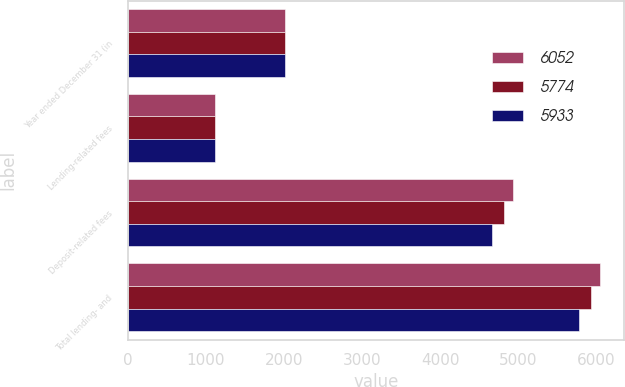<chart> <loc_0><loc_0><loc_500><loc_500><stacked_bar_chart><ecel><fcel>Year ended December 31 (in<fcel>Lending-related fees<fcel>Deposit-related fees<fcel>Total lending- and<nl><fcel>6052<fcel>2018<fcel>1117<fcel>4935<fcel>6052<nl><fcel>5774<fcel>2017<fcel>1110<fcel>4823<fcel>5933<nl><fcel>5933<fcel>2016<fcel>1114<fcel>4660<fcel>5774<nl></chart> 